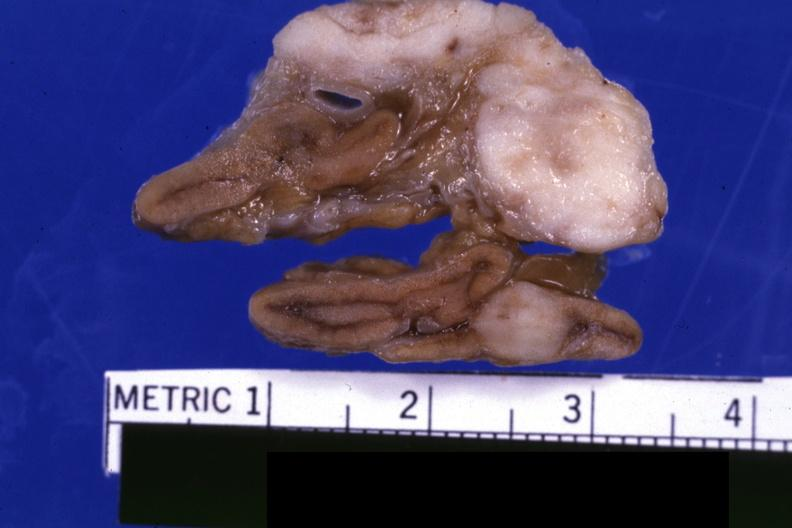s subdiaphragmatic abscess present?
Answer the question using a single word or phrase. No 